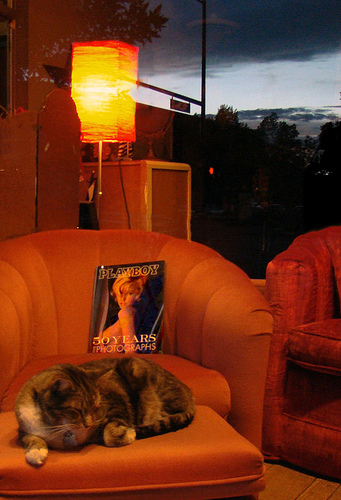<image>
Is there a cat in the chair? No. The cat is not contained within the chair. These objects have a different spatial relationship. Where is the tree in relation to the cat? Is it on the cat? No. The tree is not positioned on the cat. They may be near each other, but the tree is not supported by or resting on top of the cat. Is there a chair on the magazine? No. The chair is not positioned on the magazine. They may be near each other, but the chair is not supported by or resting on top of the magazine. 